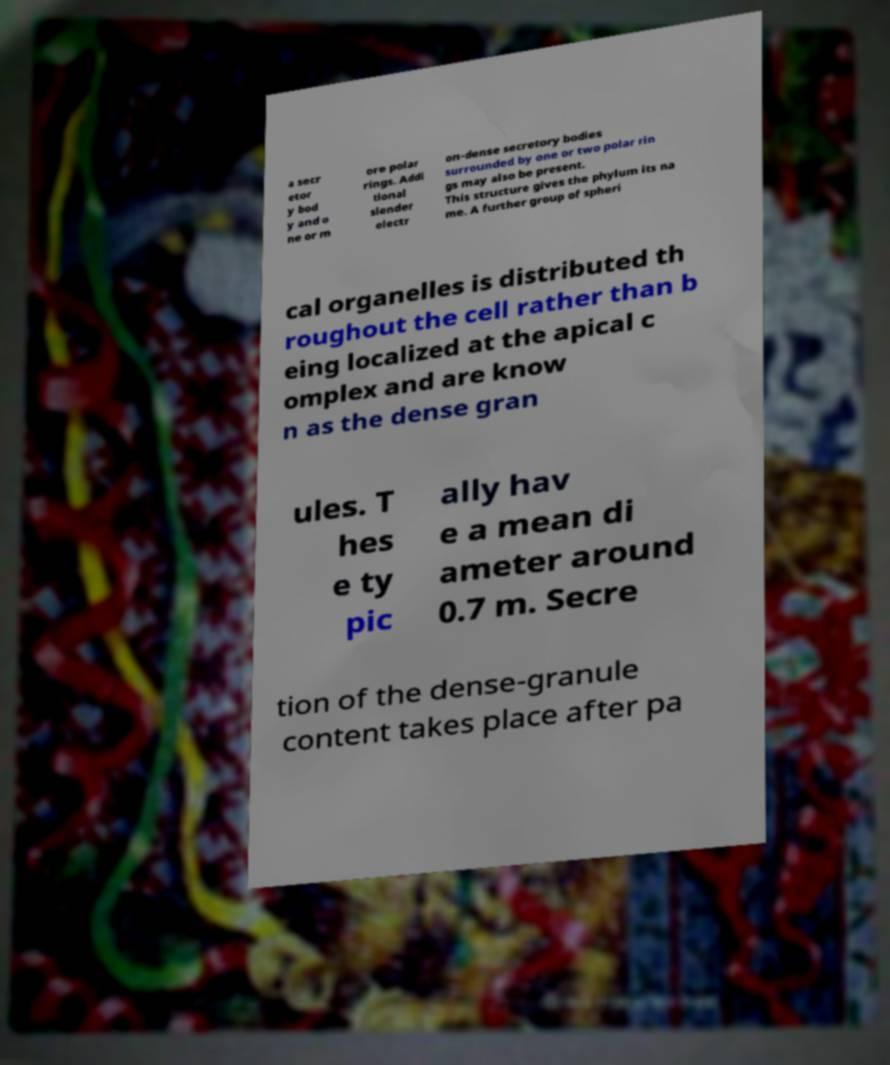Please identify and transcribe the text found in this image. a secr etor y bod y and o ne or m ore polar rings. Addi tional slender electr on-dense secretory bodies surrounded by one or two polar rin gs may also be present. This structure gives the phylum its na me. A further group of spheri cal organelles is distributed th roughout the cell rather than b eing localized at the apical c omplex and are know n as the dense gran ules. T hes e ty pic ally hav e a mean di ameter around 0.7 m. Secre tion of the dense-granule content takes place after pa 